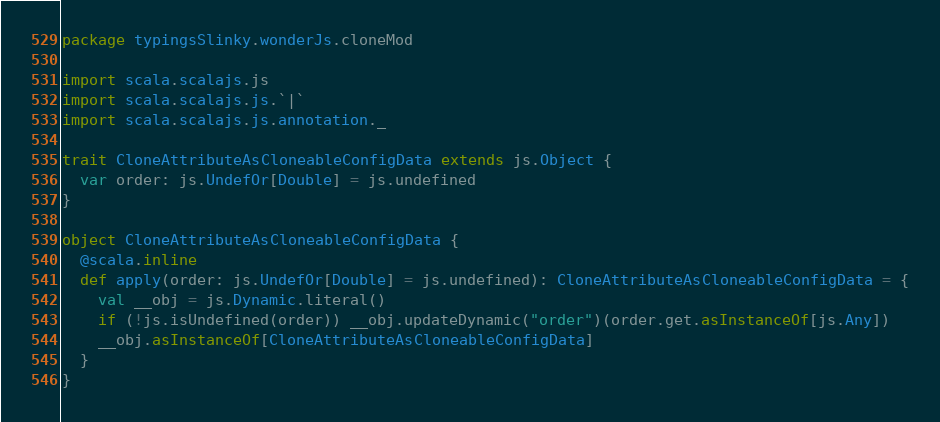<code> <loc_0><loc_0><loc_500><loc_500><_Scala_>package typingsSlinky.wonderJs.cloneMod

import scala.scalajs.js
import scala.scalajs.js.`|`
import scala.scalajs.js.annotation._

trait CloneAttributeAsCloneableConfigData extends js.Object {
  var order: js.UndefOr[Double] = js.undefined
}

object CloneAttributeAsCloneableConfigData {
  @scala.inline
  def apply(order: js.UndefOr[Double] = js.undefined): CloneAttributeAsCloneableConfigData = {
    val __obj = js.Dynamic.literal()
    if (!js.isUndefined(order)) __obj.updateDynamic("order")(order.get.asInstanceOf[js.Any])
    __obj.asInstanceOf[CloneAttributeAsCloneableConfigData]
  }
}

</code> 